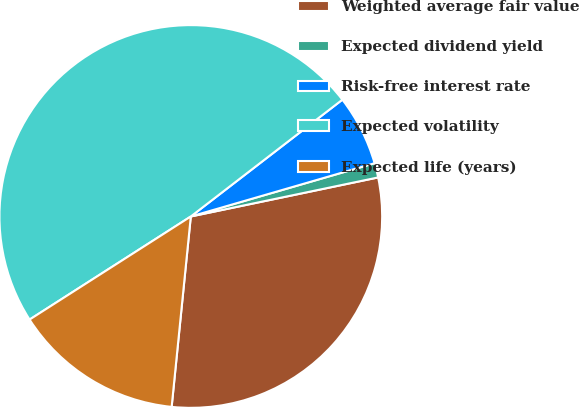Convert chart. <chart><loc_0><loc_0><loc_500><loc_500><pie_chart><fcel>Weighted average fair value<fcel>Expected dividend yield<fcel>Risk-free interest rate<fcel>Expected volatility<fcel>Expected life (years)<nl><fcel>29.87%<fcel>1.22%<fcel>5.96%<fcel>48.61%<fcel>14.35%<nl></chart> 